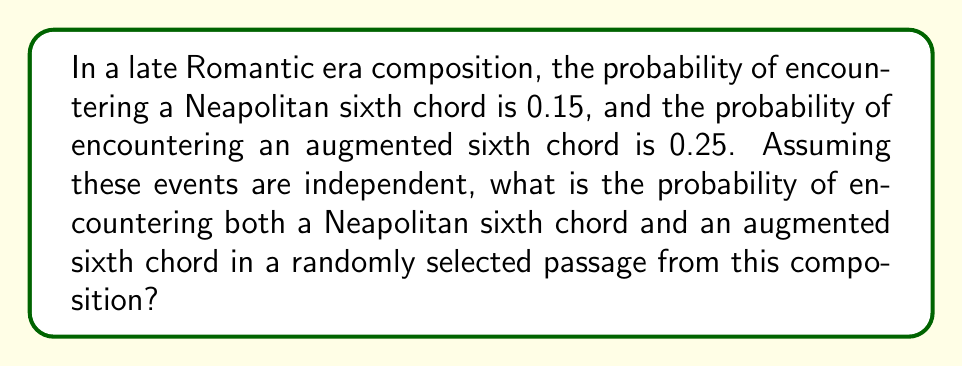Help me with this question. To solve this problem, we'll use the multiplication rule for independent events:

1) Let's define our events:
   N = event of encountering a Neapolitan sixth chord
   A = event of encountering an augmented sixth chord

2) Given probabilities:
   P(N) = 0.15
   P(A) = 0.25

3) We want to find P(N and A). Since the events are independent:
   
   P(N and A) = P(N) × P(A)

4) Substituting the given probabilities:

   P(N and A) = 0.15 × 0.25

5) Calculating:

   P(N and A) = 0.0375

Therefore, the probability of encountering both a Neapolitan sixth chord and an augmented sixth chord in a randomly selected passage is 0.0375 or 3.75%.
Answer: 0.0375 